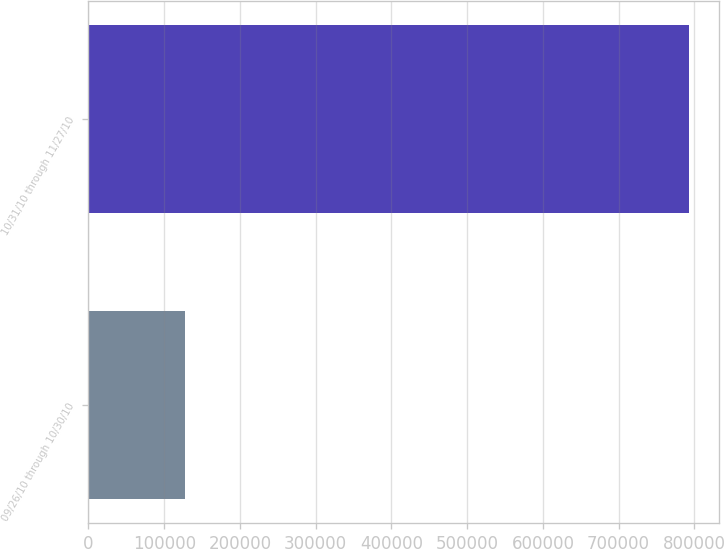Convert chart. <chart><loc_0><loc_0><loc_500><loc_500><bar_chart><fcel>09/26/10 through 10/30/10<fcel>10/31/10 through 11/27/10<nl><fcel>127085<fcel>792613<nl></chart> 